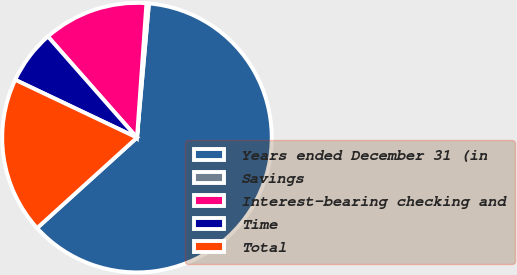Convert chart. <chart><loc_0><loc_0><loc_500><loc_500><pie_chart><fcel>Years ended December 31 (in<fcel>Savings<fcel>Interest-bearing checking and<fcel>Time<fcel>Total<nl><fcel>61.87%<fcel>0.3%<fcel>12.61%<fcel>6.45%<fcel>18.77%<nl></chart> 